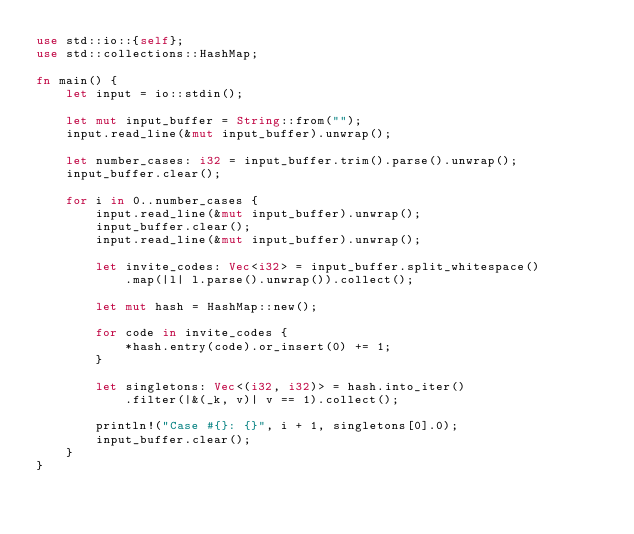<code> <loc_0><loc_0><loc_500><loc_500><_Rust_>use std::io::{self};
use std::collections::HashMap;

fn main() {
    let input = io::stdin();

    let mut input_buffer = String::from("");
    input.read_line(&mut input_buffer).unwrap();

    let number_cases: i32 = input_buffer.trim().parse().unwrap();
    input_buffer.clear();

    for i in 0..number_cases {
        input.read_line(&mut input_buffer).unwrap();
        input_buffer.clear();
        input.read_line(&mut input_buffer).unwrap();

        let invite_codes: Vec<i32> = input_buffer.split_whitespace()
            .map(|l| l.parse().unwrap()).collect();

        let mut hash = HashMap::new();

        for code in invite_codes {
            *hash.entry(code).or_insert(0) += 1;
        }

        let singletons: Vec<(i32, i32)> = hash.into_iter()
            .filter(|&(_k, v)| v == 1).collect();

        println!("Case #{}: {}", i + 1, singletons[0].0);
        input_buffer.clear();
    }
}
</code> 